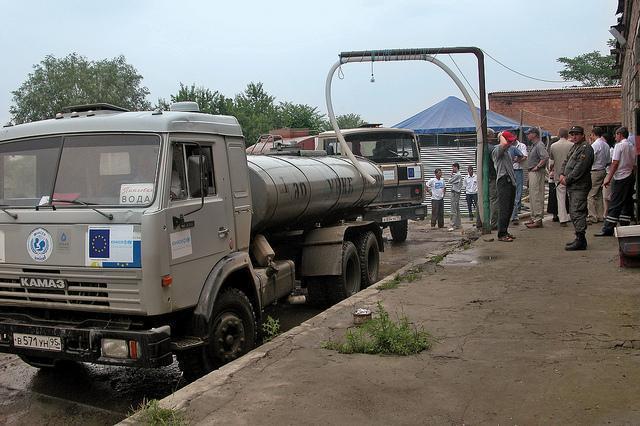How many vehicles?
Give a very brief answer. 2. How many trucks are there?
Give a very brief answer. 2. How many people are in the photo?
Give a very brief answer. 3. 